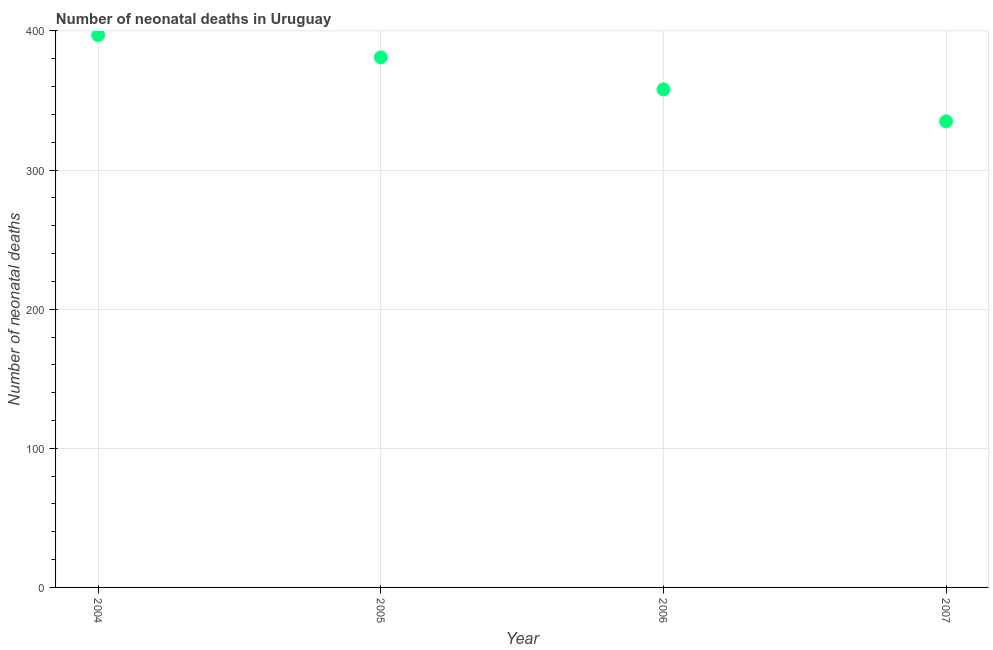What is the number of neonatal deaths in 2004?
Give a very brief answer. 397. Across all years, what is the maximum number of neonatal deaths?
Provide a succinct answer. 397. Across all years, what is the minimum number of neonatal deaths?
Provide a succinct answer. 335. What is the sum of the number of neonatal deaths?
Provide a short and direct response. 1471. What is the difference between the number of neonatal deaths in 2006 and 2007?
Your answer should be very brief. 23. What is the average number of neonatal deaths per year?
Offer a very short reply. 367.75. What is the median number of neonatal deaths?
Offer a terse response. 369.5. In how many years, is the number of neonatal deaths greater than 320 ?
Ensure brevity in your answer.  4. What is the ratio of the number of neonatal deaths in 2005 to that in 2006?
Your answer should be compact. 1.06. Is the difference between the number of neonatal deaths in 2004 and 2005 greater than the difference between any two years?
Offer a terse response. No. What is the difference between the highest and the second highest number of neonatal deaths?
Your response must be concise. 16. Is the sum of the number of neonatal deaths in 2004 and 2005 greater than the maximum number of neonatal deaths across all years?
Your answer should be very brief. Yes. What is the difference between the highest and the lowest number of neonatal deaths?
Your answer should be compact. 62. In how many years, is the number of neonatal deaths greater than the average number of neonatal deaths taken over all years?
Keep it short and to the point. 2. Does the number of neonatal deaths monotonically increase over the years?
Ensure brevity in your answer.  No. How many years are there in the graph?
Provide a succinct answer. 4. Does the graph contain any zero values?
Make the answer very short. No. Does the graph contain grids?
Your answer should be very brief. Yes. What is the title of the graph?
Keep it short and to the point. Number of neonatal deaths in Uruguay. What is the label or title of the Y-axis?
Your answer should be compact. Number of neonatal deaths. What is the Number of neonatal deaths in 2004?
Provide a succinct answer. 397. What is the Number of neonatal deaths in 2005?
Offer a terse response. 381. What is the Number of neonatal deaths in 2006?
Your answer should be compact. 358. What is the Number of neonatal deaths in 2007?
Keep it short and to the point. 335. What is the difference between the Number of neonatal deaths in 2004 and 2005?
Your answer should be very brief. 16. What is the difference between the Number of neonatal deaths in 2004 and 2007?
Your answer should be compact. 62. What is the difference between the Number of neonatal deaths in 2005 and 2006?
Provide a short and direct response. 23. What is the difference between the Number of neonatal deaths in 2005 and 2007?
Make the answer very short. 46. What is the difference between the Number of neonatal deaths in 2006 and 2007?
Your response must be concise. 23. What is the ratio of the Number of neonatal deaths in 2004 to that in 2005?
Your answer should be very brief. 1.04. What is the ratio of the Number of neonatal deaths in 2004 to that in 2006?
Provide a succinct answer. 1.11. What is the ratio of the Number of neonatal deaths in 2004 to that in 2007?
Offer a terse response. 1.19. What is the ratio of the Number of neonatal deaths in 2005 to that in 2006?
Make the answer very short. 1.06. What is the ratio of the Number of neonatal deaths in 2005 to that in 2007?
Give a very brief answer. 1.14. What is the ratio of the Number of neonatal deaths in 2006 to that in 2007?
Offer a very short reply. 1.07. 